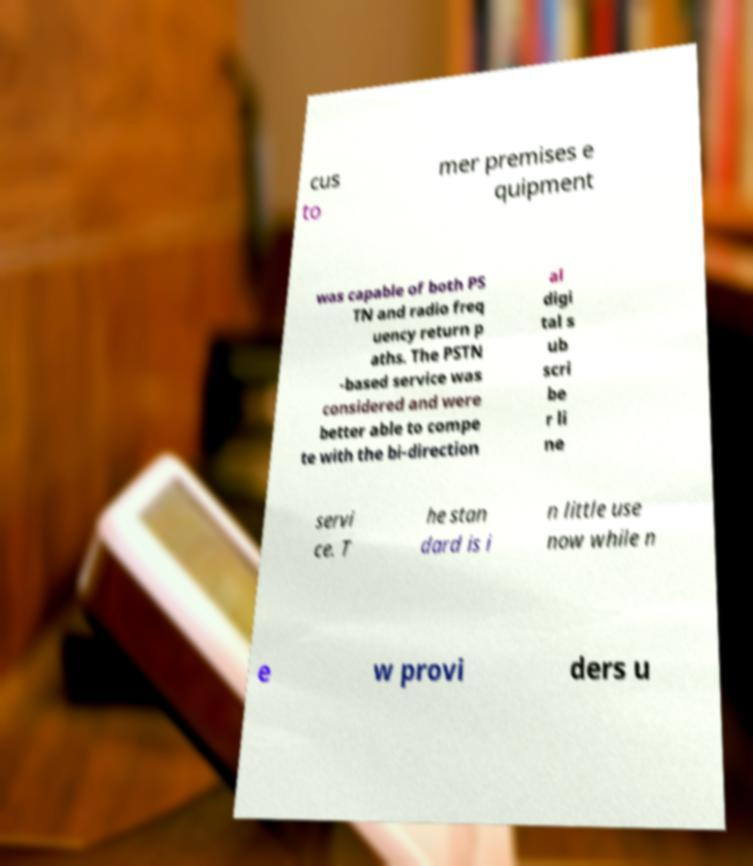What messages or text are displayed in this image? I need them in a readable, typed format. cus to mer premises e quipment was capable of both PS TN and radio freq uency return p aths. The PSTN -based service was considered and were better able to compe te with the bi-direction al digi tal s ub scri be r li ne servi ce. T he stan dard is i n little use now while n e w provi ders u 